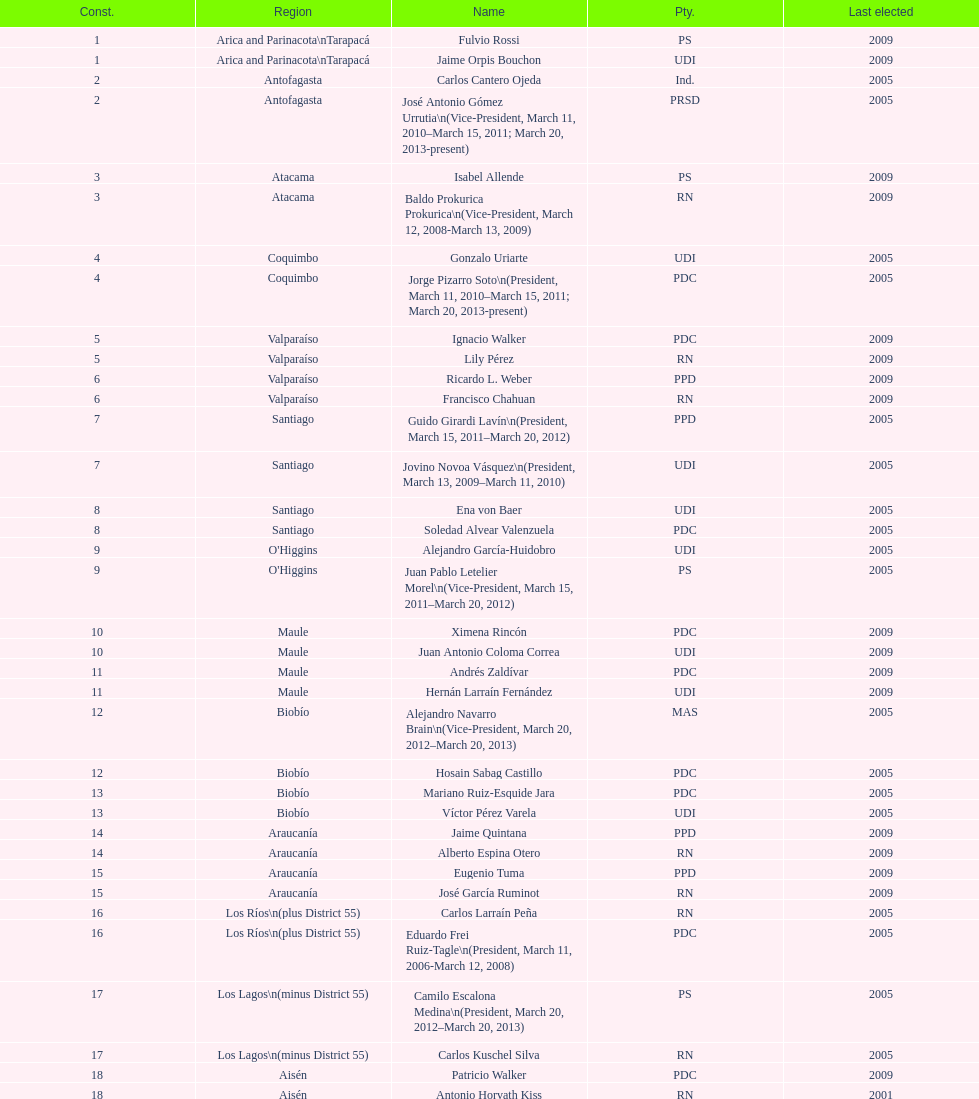What is the last region listed on the table? Magallanes. 